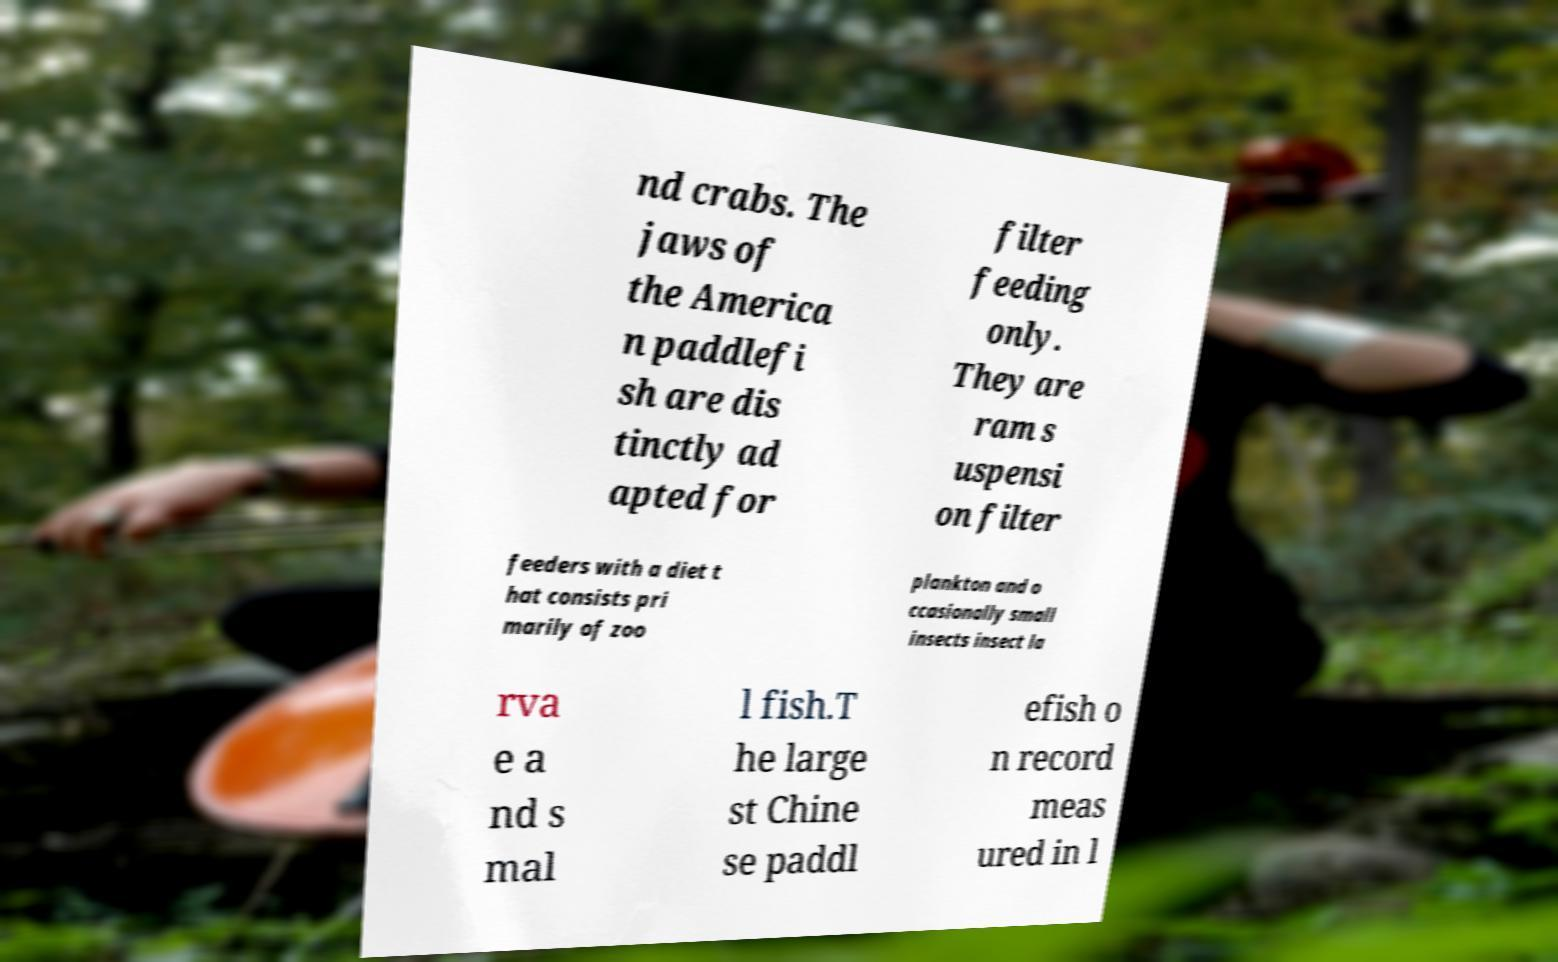Can you read and provide the text displayed in the image?This photo seems to have some interesting text. Can you extract and type it out for me? nd crabs. The jaws of the America n paddlefi sh are dis tinctly ad apted for filter feeding only. They are ram s uspensi on filter feeders with a diet t hat consists pri marily of zoo plankton and o ccasionally small insects insect la rva e a nd s mal l fish.T he large st Chine se paddl efish o n record meas ured in l 